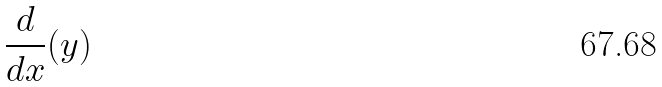<formula> <loc_0><loc_0><loc_500><loc_500>\frac { d } { d x } ( y )</formula> 